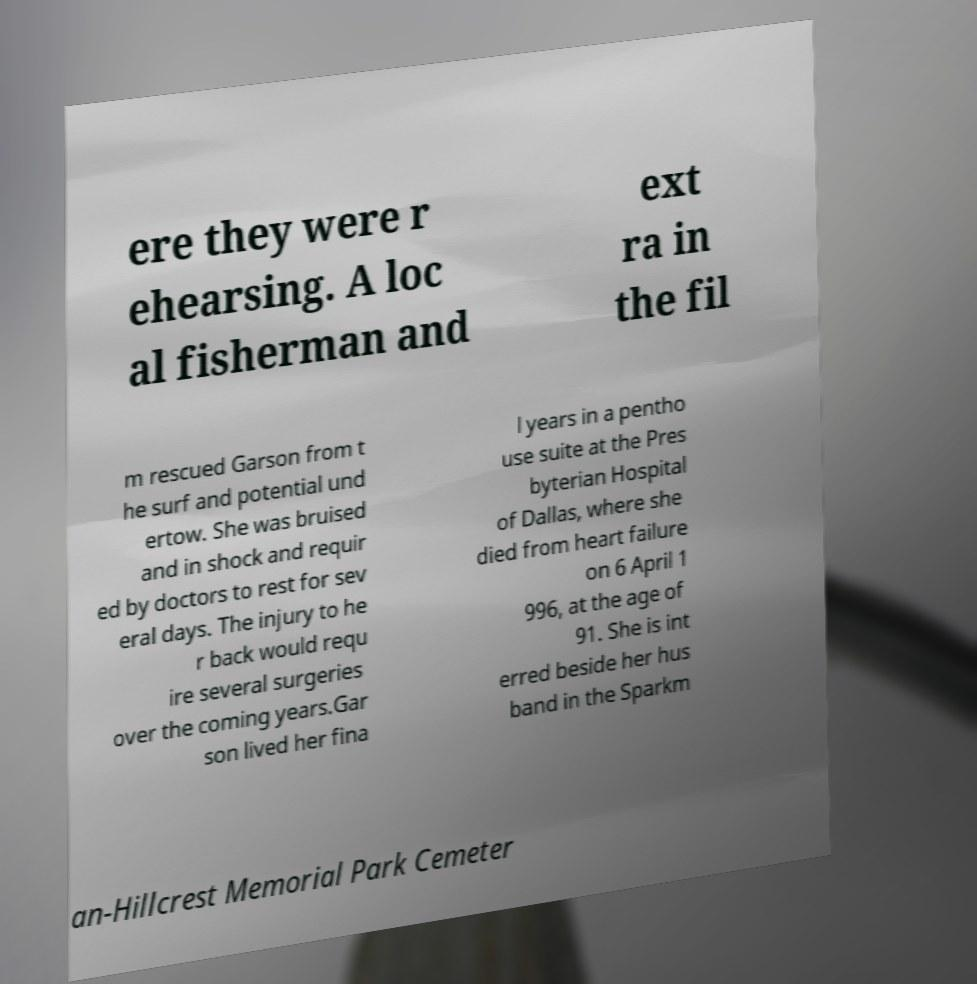Can you read and provide the text displayed in the image?This photo seems to have some interesting text. Can you extract and type it out for me? ere they were r ehearsing. A loc al fisherman and ext ra in the fil m rescued Garson from t he surf and potential und ertow. She was bruised and in shock and requir ed by doctors to rest for sev eral days. The injury to he r back would requ ire several surgeries over the coming years.Gar son lived her fina l years in a pentho use suite at the Pres byterian Hospital of Dallas, where she died from heart failure on 6 April 1 996, at the age of 91. She is int erred beside her hus band in the Sparkm an-Hillcrest Memorial Park Cemeter 